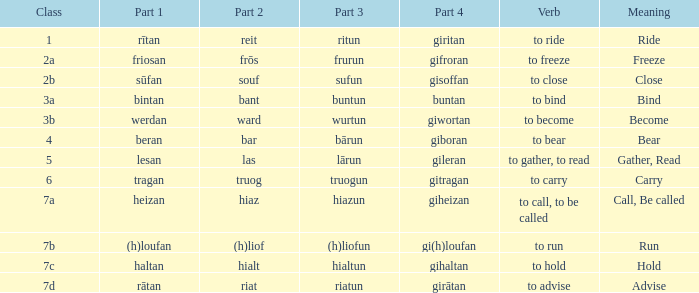What class in the word with part 4 "giheizan"? 7a. 